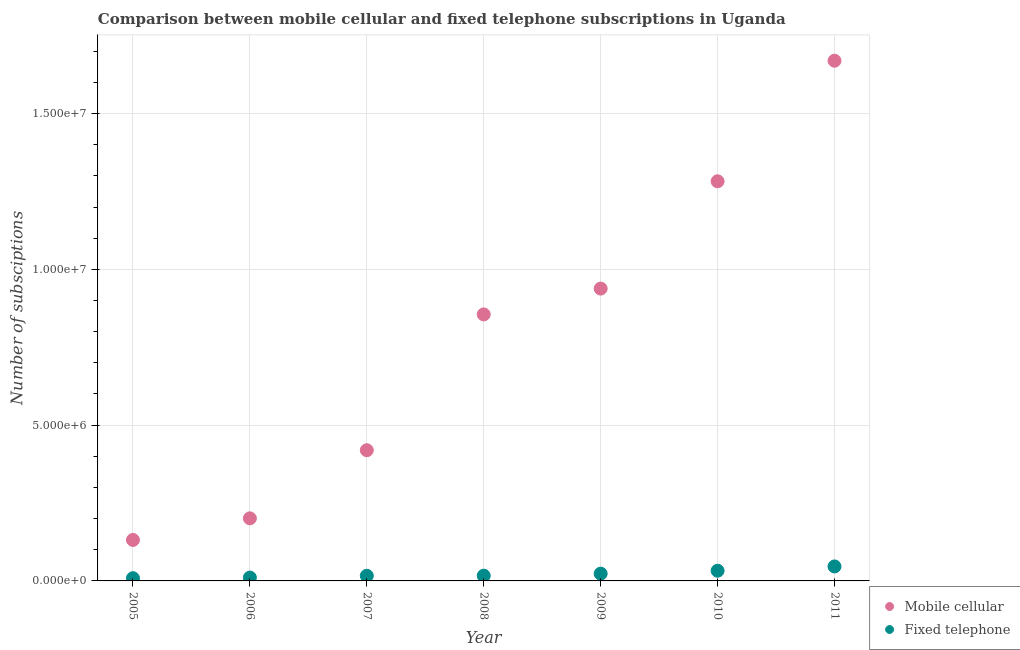How many different coloured dotlines are there?
Give a very brief answer. 2. Is the number of dotlines equal to the number of legend labels?
Give a very brief answer. Yes. What is the number of mobile cellular subscriptions in 2005?
Provide a succinct answer. 1.32e+06. Across all years, what is the maximum number of fixed telephone subscriptions?
Give a very brief answer. 4.65e+05. Across all years, what is the minimum number of fixed telephone subscriptions?
Ensure brevity in your answer.  8.75e+04. In which year was the number of fixed telephone subscriptions maximum?
Make the answer very short. 2011. What is the total number of fixed telephone subscriptions in the graph?
Provide a short and direct response. 1.56e+06. What is the difference between the number of fixed telephone subscriptions in 2005 and that in 2009?
Offer a very short reply. -1.46e+05. What is the difference between the number of mobile cellular subscriptions in 2011 and the number of fixed telephone subscriptions in 2010?
Ensure brevity in your answer.  1.64e+07. What is the average number of fixed telephone subscriptions per year?
Provide a succinct answer. 2.22e+05. In the year 2007, what is the difference between the number of fixed telephone subscriptions and number of mobile cellular subscriptions?
Offer a terse response. -4.03e+06. What is the ratio of the number of fixed telephone subscriptions in 2007 to that in 2008?
Give a very brief answer. 0.98. Is the number of fixed telephone subscriptions in 2009 less than that in 2010?
Offer a terse response. Yes. What is the difference between the highest and the second highest number of fixed telephone subscriptions?
Keep it short and to the point. 1.38e+05. What is the difference between the highest and the lowest number of fixed telephone subscriptions?
Keep it short and to the point. 3.77e+05. In how many years, is the number of mobile cellular subscriptions greater than the average number of mobile cellular subscriptions taken over all years?
Provide a short and direct response. 4. Does the number of mobile cellular subscriptions monotonically increase over the years?
Keep it short and to the point. Yes. How many dotlines are there?
Ensure brevity in your answer.  2. How many years are there in the graph?
Offer a terse response. 7. Does the graph contain any zero values?
Your answer should be compact. No. Does the graph contain grids?
Your response must be concise. Yes. Where does the legend appear in the graph?
Your answer should be very brief. Bottom right. How are the legend labels stacked?
Keep it short and to the point. Vertical. What is the title of the graph?
Ensure brevity in your answer.  Comparison between mobile cellular and fixed telephone subscriptions in Uganda. Does "Domestic liabilities" appear as one of the legend labels in the graph?
Provide a short and direct response. No. What is the label or title of the Y-axis?
Keep it short and to the point. Number of subsciptions. What is the Number of subsciptions of Mobile cellular in 2005?
Provide a succinct answer. 1.32e+06. What is the Number of subsciptions of Fixed telephone in 2005?
Provide a short and direct response. 8.75e+04. What is the Number of subsciptions in Mobile cellular in 2006?
Provide a short and direct response. 2.01e+06. What is the Number of subsciptions in Fixed telephone in 2006?
Make the answer very short. 1.08e+05. What is the Number of subsciptions in Mobile cellular in 2007?
Offer a terse response. 4.20e+06. What is the Number of subsciptions of Fixed telephone in 2007?
Keep it short and to the point. 1.66e+05. What is the Number of subsciptions of Mobile cellular in 2008?
Your answer should be compact. 8.55e+06. What is the Number of subsciptions of Fixed telephone in 2008?
Give a very brief answer. 1.68e+05. What is the Number of subsciptions in Mobile cellular in 2009?
Make the answer very short. 9.38e+06. What is the Number of subsciptions of Fixed telephone in 2009?
Keep it short and to the point. 2.34e+05. What is the Number of subsciptions of Mobile cellular in 2010?
Offer a very short reply. 1.28e+07. What is the Number of subsciptions of Fixed telephone in 2010?
Give a very brief answer. 3.27e+05. What is the Number of subsciptions in Mobile cellular in 2011?
Ensure brevity in your answer.  1.67e+07. What is the Number of subsciptions in Fixed telephone in 2011?
Offer a very short reply. 4.65e+05. Across all years, what is the maximum Number of subsciptions in Mobile cellular?
Give a very brief answer. 1.67e+07. Across all years, what is the maximum Number of subsciptions of Fixed telephone?
Provide a succinct answer. 4.65e+05. Across all years, what is the minimum Number of subsciptions of Mobile cellular?
Provide a short and direct response. 1.32e+06. Across all years, what is the minimum Number of subsciptions in Fixed telephone?
Make the answer very short. 8.75e+04. What is the total Number of subsciptions in Mobile cellular in the graph?
Offer a very short reply. 5.50e+07. What is the total Number of subsciptions in Fixed telephone in the graph?
Give a very brief answer. 1.56e+06. What is the difference between the Number of subsciptions in Mobile cellular in 2005 and that in 2006?
Provide a succinct answer. -6.94e+05. What is the difference between the Number of subsciptions of Fixed telephone in 2005 and that in 2006?
Your answer should be very brief. -2.06e+04. What is the difference between the Number of subsciptions of Mobile cellular in 2005 and that in 2007?
Ensure brevity in your answer.  -2.88e+06. What is the difference between the Number of subsciptions of Fixed telephone in 2005 and that in 2007?
Offer a terse response. -7.83e+04. What is the difference between the Number of subsciptions in Mobile cellular in 2005 and that in 2008?
Offer a very short reply. -7.24e+06. What is the difference between the Number of subsciptions in Fixed telephone in 2005 and that in 2008?
Provide a short and direct response. -8.10e+04. What is the difference between the Number of subsciptions of Mobile cellular in 2005 and that in 2009?
Keep it short and to the point. -8.07e+06. What is the difference between the Number of subsciptions of Fixed telephone in 2005 and that in 2009?
Offer a terse response. -1.46e+05. What is the difference between the Number of subsciptions of Mobile cellular in 2005 and that in 2010?
Offer a very short reply. -1.15e+07. What is the difference between the Number of subsciptions in Fixed telephone in 2005 and that in 2010?
Your response must be concise. -2.40e+05. What is the difference between the Number of subsciptions of Mobile cellular in 2005 and that in 2011?
Offer a very short reply. -1.54e+07. What is the difference between the Number of subsciptions in Fixed telephone in 2005 and that in 2011?
Your answer should be very brief. -3.77e+05. What is the difference between the Number of subsciptions of Mobile cellular in 2006 and that in 2007?
Your answer should be compact. -2.19e+06. What is the difference between the Number of subsciptions in Fixed telephone in 2006 and that in 2007?
Offer a terse response. -5.76e+04. What is the difference between the Number of subsciptions in Mobile cellular in 2006 and that in 2008?
Offer a very short reply. -6.55e+06. What is the difference between the Number of subsciptions of Fixed telephone in 2006 and that in 2008?
Offer a terse response. -6.03e+04. What is the difference between the Number of subsciptions of Mobile cellular in 2006 and that in 2009?
Provide a succinct answer. -7.37e+06. What is the difference between the Number of subsciptions of Fixed telephone in 2006 and that in 2009?
Your answer should be compact. -1.25e+05. What is the difference between the Number of subsciptions of Mobile cellular in 2006 and that in 2010?
Offer a terse response. -1.08e+07. What is the difference between the Number of subsciptions of Fixed telephone in 2006 and that in 2010?
Make the answer very short. -2.19e+05. What is the difference between the Number of subsciptions of Mobile cellular in 2006 and that in 2011?
Your response must be concise. -1.47e+07. What is the difference between the Number of subsciptions in Fixed telephone in 2006 and that in 2011?
Give a very brief answer. -3.57e+05. What is the difference between the Number of subsciptions in Mobile cellular in 2007 and that in 2008?
Your response must be concise. -4.36e+06. What is the difference between the Number of subsciptions in Fixed telephone in 2007 and that in 2008?
Keep it short and to the point. -2693. What is the difference between the Number of subsciptions in Mobile cellular in 2007 and that in 2009?
Provide a short and direct response. -5.19e+06. What is the difference between the Number of subsciptions of Fixed telephone in 2007 and that in 2009?
Your answer should be very brief. -6.77e+04. What is the difference between the Number of subsciptions of Mobile cellular in 2007 and that in 2010?
Offer a terse response. -8.63e+06. What is the difference between the Number of subsciptions in Fixed telephone in 2007 and that in 2010?
Provide a succinct answer. -1.61e+05. What is the difference between the Number of subsciptions in Mobile cellular in 2007 and that in 2011?
Offer a terse response. -1.25e+07. What is the difference between the Number of subsciptions of Fixed telephone in 2007 and that in 2011?
Provide a succinct answer. -2.99e+05. What is the difference between the Number of subsciptions of Mobile cellular in 2008 and that in 2009?
Provide a succinct answer. -8.29e+05. What is the difference between the Number of subsciptions in Fixed telephone in 2008 and that in 2009?
Offer a very short reply. -6.51e+04. What is the difference between the Number of subsciptions in Mobile cellular in 2008 and that in 2010?
Provide a succinct answer. -4.27e+06. What is the difference between the Number of subsciptions in Fixed telephone in 2008 and that in 2010?
Offer a very short reply. -1.59e+05. What is the difference between the Number of subsciptions in Mobile cellular in 2008 and that in 2011?
Make the answer very short. -8.14e+06. What is the difference between the Number of subsciptions in Fixed telephone in 2008 and that in 2011?
Your answer should be compact. -2.96e+05. What is the difference between the Number of subsciptions in Mobile cellular in 2009 and that in 2010?
Keep it short and to the point. -3.44e+06. What is the difference between the Number of subsciptions in Fixed telephone in 2009 and that in 2010?
Offer a terse response. -9.36e+04. What is the difference between the Number of subsciptions of Mobile cellular in 2009 and that in 2011?
Provide a short and direct response. -7.31e+06. What is the difference between the Number of subsciptions in Fixed telephone in 2009 and that in 2011?
Give a very brief answer. -2.31e+05. What is the difference between the Number of subsciptions of Mobile cellular in 2010 and that in 2011?
Your answer should be compact. -3.87e+06. What is the difference between the Number of subsciptions of Fixed telephone in 2010 and that in 2011?
Give a very brief answer. -1.38e+05. What is the difference between the Number of subsciptions in Mobile cellular in 2005 and the Number of subsciptions in Fixed telephone in 2006?
Provide a short and direct response. 1.21e+06. What is the difference between the Number of subsciptions in Mobile cellular in 2005 and the Number of subsciptions in Fixed telephone in 2007?
Provide a succinct answer. 1.15e+06. What is the difference between the Number of subsciptions in Mobile cellular in 2005 and the Number of subsciptions in Fixed telephone in 2008?
Provide a short and direct response. 1.15e+06. What is the difference between the Number of subsciptions in Mobile cellular in 2005 and the Number of subsciptions in Fixed telephone in 2009?
Provide a short and direct response. 1.08e+06. What is the difference between the Number of subsciptions of Mobile cellular in 2005 and the Number of subsciptions of Fixed telephone in 2010?
Offer a very short reply. 9.88e+05. What is the difference between the Number of subsciptions in Mobile cellular in 2005 and the Number of subsciptions in Fixed telephone in 2011?
Your answer should be very brief. 8.50e+05. What is the difference between the Number of subsciptions of Mobile cellular in 2006 and the Number of subsciptions of Fixed telephone in 2007?
Provide a succinct answer. 1.84e+06. What is the difference between the Number of subsciptions of Mobile cellular in 2006 and the Number of subsciptions of Fixed telephone in 2008?
Provide a succinct answer. 1.84e+06. What is the difference between the Number of subsciptions of Mobile cellular in 2006 and the Number of subsciptions of Fixed telephone in 2009?
Your answer should be compact. 1.78e+06. What is the difference between the Number of subsciptions of Mobile cellular in 2006 and the Number of subsciptions of Fixed telephone in 2010?
Offer a very short reply. 1.68e+06. What is the difference between the Number of subsciptions in Mobile cellular in 2006 and the Number of subsciptions in Fixed telephone in 2011?
Give a very brief answer. 1.54e+06. What is the difference between the Number of subsciptions of Mobile cellular in 2007 and the Number of subsciptions of Fixed telephone in 2008?
Your answer should be compact. 4.03e+06. What is the difference between the Number of subsciptions in Mobile cellular in 2007 and the Number of subsciptions in Fixed telephone in 2009?
Give a very brief answer. 3.96e+06. What is the difference between the Number of subsciptions in Mobile cellular in 2007 and the Number of subsciptions in Fixed telephone in 2010?
Give a very brief answer. 3.87e+06. What is the difference between the Number of subsciptions in Mobile cellular in 2007 and the Number of subsciptions in Fixed telephone in 2011?
Your answer should be very brief. 3.73e+06. What is the difference between the Number of subsciptions in Mobile cellular in 2008 and the Number of subsciptions in Fixed telephone in 2009?
Offer a very short reply. 8.32e+06. What is the difference between the Number of subsciptions in Mobile cellular in 2008 and the Number of subsciptions in Fixed telephone in 2010?
Offer a terse response. 8.23e+06. What is the difference between the Number of subsciptions of Mobile cellular in 2008 and the Number of subsciptions of Fixed telephone in 2011?
Make the answer very short. 8.09e+06. What is the difference between the Number of subsciptions of Mobile cellular in 2009 and the Number of subsciptions of Fixed telephone in 2010?
Make the answer very short. 9.06e+06. What is the difference between the Number of subsciptions in Mobile cellular in 2009 and the Number of subsciptions in Fixed telephone in 2011?
Keep it short and to the point. 8.92e+06. What is the difference between the Number of subsciptions in Mobile cellular in 2010 and the Number of subsciptions in Fixed telephone in 2011?
Offer a terse response. 1.24e+07. What is the average Number of subsciptions in Mobile cellular per year?
Give a very brief answer. 7.85e+06. What is the average Number of subsciptions of Fixed telephone per year?
Keep it short and to the point. 2.22e+05. In the year 2005, what is the difference between the Number of subsciptions of Mobile cellular and Number of subsciptions of Fixed telephone?
Your response must be concise. 1.23e+06. In the year 2006, what is the difference between the Number of subsciptions of Mobile cellular and Number of subsciptions of Fixed telephone?
Your response must be concise. 1.90e+06. In the year 2007, what is the difference between the Number of subsciptions in Mobile cellular and Number of subsciptions in Fixed telephone?
Make the answer very short. 4.03e+06. In the year 2008, what is the difference between the Number of subsciptions of Mobile cellular and Number of subsciptions of Fixed telephone?
Ensure brevity in your answer.  8.39e+06. In the year 2009, what is the difference between the Number of subsciptions of Mobile cellular and Number of subsciptions of Fixed telephone?
Your answer should be very brief. 9.15e+06. In the year 2010, what is the difference between the Number of subsciptions of Mobile cellular and Number of subsciptions of Fixed telephone?
Your answer should be compact. 1.25e+07. In the year 2011, what is the difference between the Number of subsciptions of Mobile cellular and Number of subsciptions of Fixed telephone?
Make the answer very short. 1.62e+07. What is the ratio of the Number of subsciptions in Mobile cellular in 2005 to that in 2006?
Provide a short and direct response. 0.65. What is the ratio of the Number of subsciptions of Fixed telephone in 2005 to that in 2006?
Provide a short and direct response. 0.81. What is the ratio of the Number of subsciptions in Mobile cellular in 2005 to that in 2007?
Ensure brevity in your answer.  0.31. What is the ratio of the Number of subsciptions of Fixed telephone in 2005 to that in 2007?
Provide a short and direct response. 0.53. What is the ratio of the Number of subsciptions in Mobile cellular in 2005 to that in 2008?
Ensure brevity in your answer.  0.15. What is the ratio of the Number of subsciptions of Fixed telephone in 2005 to that in 2008?
Your answer should be compact. 0.52. What is the ratio of the Number of subsciptions of Mobile cellular in 2005 to that in 2009?
Offer a terse response. 0.14. What is the ratio of the Number of subsciptions of Fixed telephone in 2005 to that in 2009?
Provide a short and direct response. 0.37. What is the ratio of the Number of subsciptions in Mobile cellular in 2005 to that in 2010?
Provide a succinct answer. 0.1. What is the ratio of the Number of subsciptions of Fixed telephone in 2005 to that in 2010?
Ensure brevity in your answer.  0.27. What is the ratio of the Number of subsciptions of Mobile cellular in 2005 to that in 2011?
Offer a very short reply. 0.08. What is the ratio of the Number of subsciptions of Fixed telephone in 2005 to that in 2011?
Your answer should be compact. 0.19. What is the ratio of the Number of subsciptions of Mobile cellular in 2006 to that in 2007?
Your answer should be compact. 0.48. What is the ratio of the Number of subsciptions in Fixed telephone in 2006 to that in 2007?
Your answer should be compact. 0.65. What is the ratio of the Number of subsciptions of Mobile cellular in 2006 to that in 2008?
Provide a succinct answer. 0.23. What is the ratio of the Number of subsciptions in Fixed telephone in 2006 to that in 2008?
Offer a terse response. 0.64. What is the ratio of the Number of subsciptions in Mobile cellular in 2006 to that in 2009?
Make the answer very short. 0.21. What is the ratio of the Number of subsciptions of Fixed telephone in 2006 to that in 2009?
Provide a short and direct response. 0.46. What is the ratio of the Number of subsciptions of Mobile cellular in 2006 to that in 2010?
Your answer should be very brief. 0.16. What is the ratio of the Number of subsciptions in Fixed telephone in 2006 to that in 2010?
Your response must be concise. 0.33. What is the ratio of the Number of subsciptions in Mobile cellular in 2006 to that in 2011?
Offer a very short reply. 0.12. What is the ratio of the Number of subsciptions in Fixed telephone in 2006 to that in 2011?
Provide a succinct answer. 0.23. What is the ratio of the Number of subsciptions of Mobile cellular in 2007 to that in 2008?
Offer a very short reply. 0.49. What is the ratio of the Number of subsciptions of Fixed telephone in 2007 to that in 2008?
Ensure brevity in your answer.  0.98. What is the ratio of the Number of subsciptions of Mobile cellular in 2007 to that in 2009?
Offer a terse response. 0.45. What is the ratio of the Number of subsciptions of Fixed telephone in 2007 to that in 2009?
Offer a very short reply. 0.71. What is the ratio of the Number of subsciptions in Mobile cellular in 2007 to that in 2010?
Your response must be concise. 0.33. What is the ratio of the Number of subsciptions in Fixed telephone in 2007 to that in 2010?
Offer a very short reply. 0.51. What is the ratio of the Number of subsciptions in Mobile cellular in 2007 to that in 2011?
Offer a terse response. 0.25. What is the ratio of the Number of subsciptions of Fixed telephone in 2007 to that in 2011?
Make the answer very short. 0.36. What is the ratio of the Number of subsciptions of Mobile cellular in 2008 to that in 2009?
Give a very brief answer. 0.91. What is the ratio of the Number of subsciptions in Fixed telephone in 2008 to that in 2009?
Your answer should be very brief. 0.72. What is the ratio of the Number of subsciptions of Mobile cellular in 2008 to that in 2010?
Give a very brief answer. 0.67. What is the ratio of the Number of subsciptions of Fixed telephone in 2008 to that in 2010?
Make the answer very short. 0.52. What is the ratio of the Number of subsciptions of Mobile cellular in 2008 to that in 2011?
Offer a terse response. 0.51. What is the ratio of the Number of subsciptions in Fixed telephone in 2008 to that in 2011?
Your answer should be compact. 0.36. What is the ratio of the Number of subsciptions of Mobile cellular in 2009 to that in 2010?
Your answer should be compact. 0.73. What is the ratio of the Number of subsciptions of Fixed telephone in 2009 to that in 2010?
Give a very brief answer. 0.71. What is the ratio of the Number of subsciptions of Mobile cellular in 2009 to that in 2011?
Make the answer very short. 0.56. What is the ratio of the Number of subsciptions of Fixed telephone in 2009 to that in 2011?
Offer a terse response. 0.5. What is the ratio of the Number of subsciptions of Mobile cellular in 2010 to that in 2011?
Give a very brief answer. 0.77. What is the ratio of the Number of subsciptions in Fixed telephone in 2010 to that in 2011?
Keep it short and to the point. 0.7. What is the difference between the highest and the second highest Number of subsciptions in Mobile cellular?
Make the answer very short. 3.87e+06. What is the difference between the highest and the second highest Number of subsciptions in Fixed telephone?
Your response must be concise. 1.38e+05. What is the difference between the highest and the lowest Number of subsciptions in Mobile cellular?
Provide a short and direct response. 1.54e+07. What is the difference between the highest and the lowest Number of subsciptions in Fixed telephone?
Offer a terse response. 3.77e+05. 